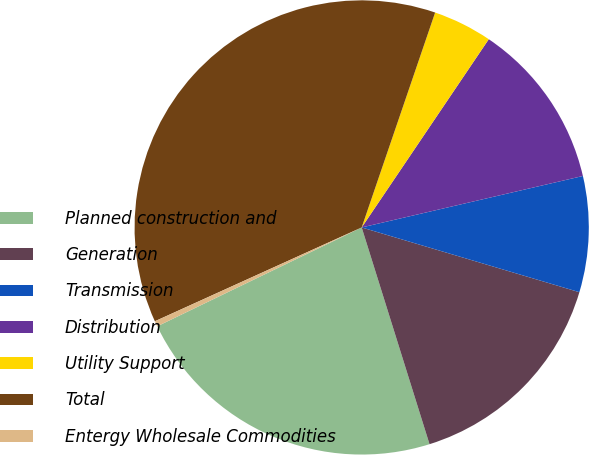Convert chart to OTSL. <chart><loc_0><loc_0><loc_500><loc_500><pie_chart><fcel>Planned construction and<fcel>Generation<fcel>Transmission<fcel>Distribution<fcel>Utility Support<fcel>Total<fcel>Entergy Wholesale Commodities<nl><fcel>22.66%<fcel>15.57%<fcel>8.24%<fcel>11.91%<fcel>4.21%<fcel>37.02%<fcel>0.39%<nl></chart> 